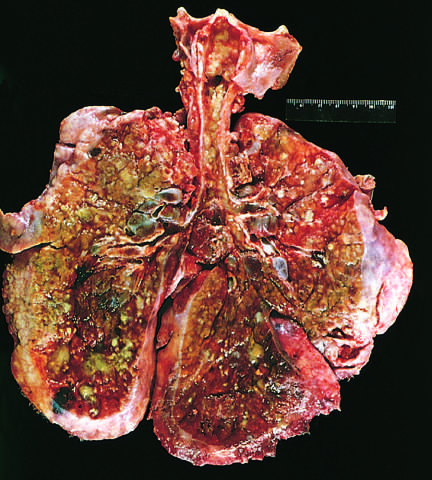re low-power view of a thrombosed artery apparent?
Answer the question using a single word or phrase. No 